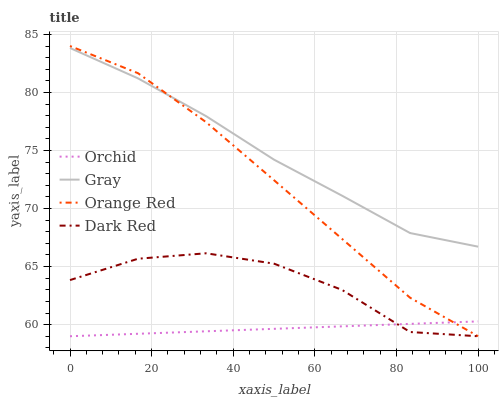Does Dark Red have the minimum area under the curve?
Answer yes or no. No. Does Dark Red have the maximum area under the curve?
Answer yes or no. No. Is Orange Red the smoothest?
Answer yes or no. No. Is Orange Red the roughest?
Answer yes or no. No. Does Dark Red have the highest value?
Answer yes or no. No. Is Dark Red less than Gray?
Answer yes or no. Yes. Is Gray greater than Dark Red?
Answer yes or no. Yes. Does Dark Red intersect Gray?
Answer yes or no. No. 